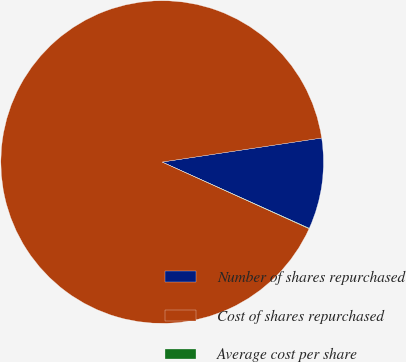Convert chart. <chart><loc_0><loc_0><loc_500><loc_500><pie_chart><fcel>Number of shares repurchased<fcel>Cost of shares repurchased<fcel>Average cost per share<nl><fcel>9.12%<fcel>90.84%<fcel>0.04%<nl></chart> 